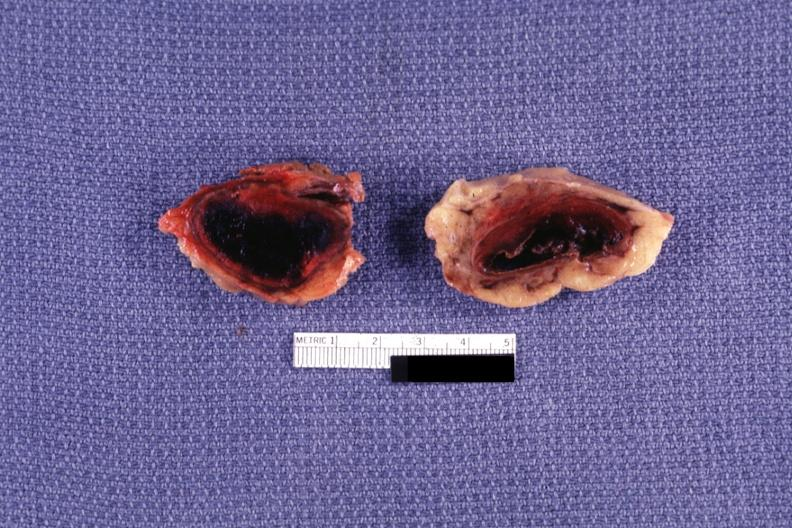s adrenal present?
Answer the question using a single word or phrase. Yes 